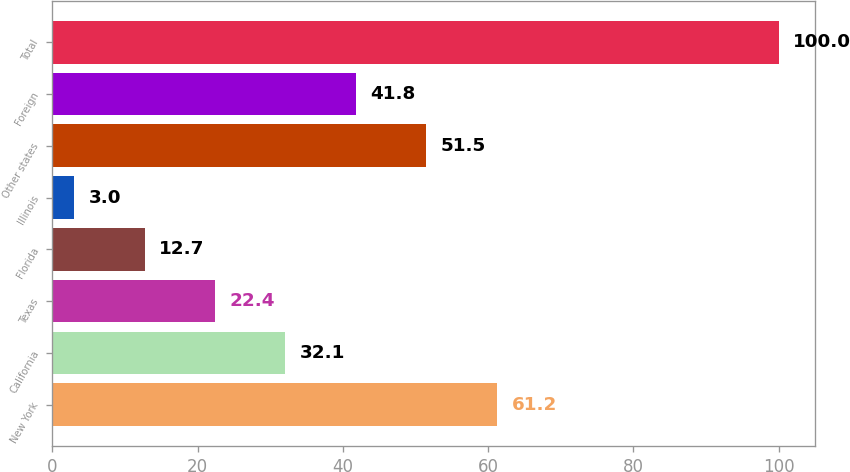<chart> <loc_0><loc_0><loc_500><loc_500><bar_chart><fcel>New York<fcel>California<fcel>Texas<fcel>Florida<fcel>Illinois<fcel>Other states<fcel>Foreign<fcel>Total<nl><fcel>61.2<fcel>32.1<fcel>22.4<fcel>12.7<fcel>3<fcel>51.5<fcel>41.8<fcel>100<nl></chart> 